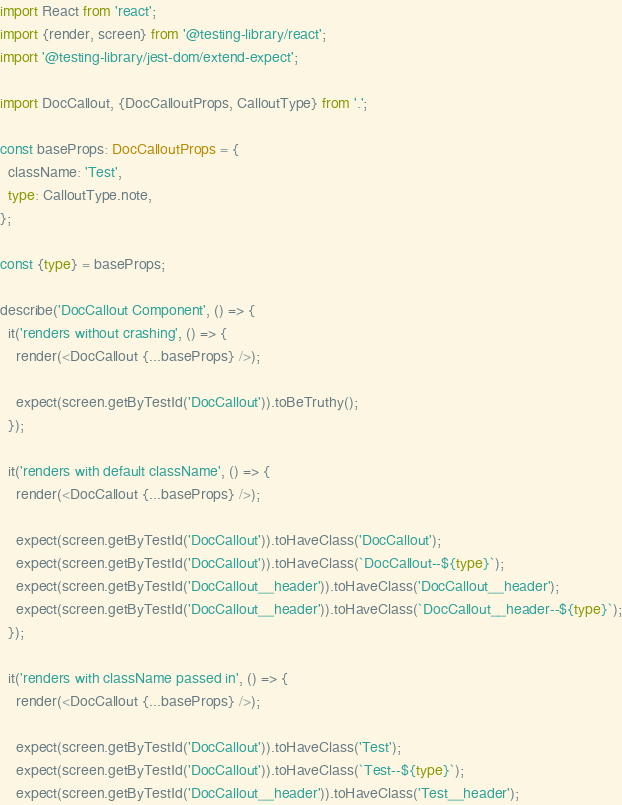<code> <loc_0><loc_0><loc_500><loc_500><_TypeScript_>import React from 'react';
import {render, screen} from '@testing-library/react';
import '@testing-library/jest-dom/extend-expect';

import DocCallout, {DocCalloutProps, CalloutType} from '.';

const baseProps: DocCalloutProps = {
  className: 'Test',
  type: CalloutType.note,
};

const {type} = baseProps;

describe('DocCallout Component', () => {
  it('renders without crashing', () => {
    render(<DocCallout {...baseProps} />);

    expect(screen.getByTestId('DocCallout')).toBeTruthy();
  });

  it('renders with default className', () => {
    render(<DocCallout {...baseProps} />);

    expect(screen.getByTestId('DocCallout')).toHaveClass('DocCallout');
    expect(screen.getByTestId('DocCallout')).toHaveClass(`DocCallout--${type}`);
    expect(screen.getByTestId('DocCallout__header')).toHaveClass('DocCallout__header');
    expect(screen.getByTestId('DocCallout__header')).toHaveClass(`DocCallout__header--${type}`);
  });

  it('renders with className passed in', () => {
    render(<DocCallout {...baseProps} />);

    expect(screen.getByTestId('DocCallout')).toHaveClass('Test');
    expect(screen.getByTestId('DocCallout')).toHaveClass(`Test--${type}`);
    expect(screen.getByTestId('DocCallout__header')).toHaveClass('Test__header');</code> 